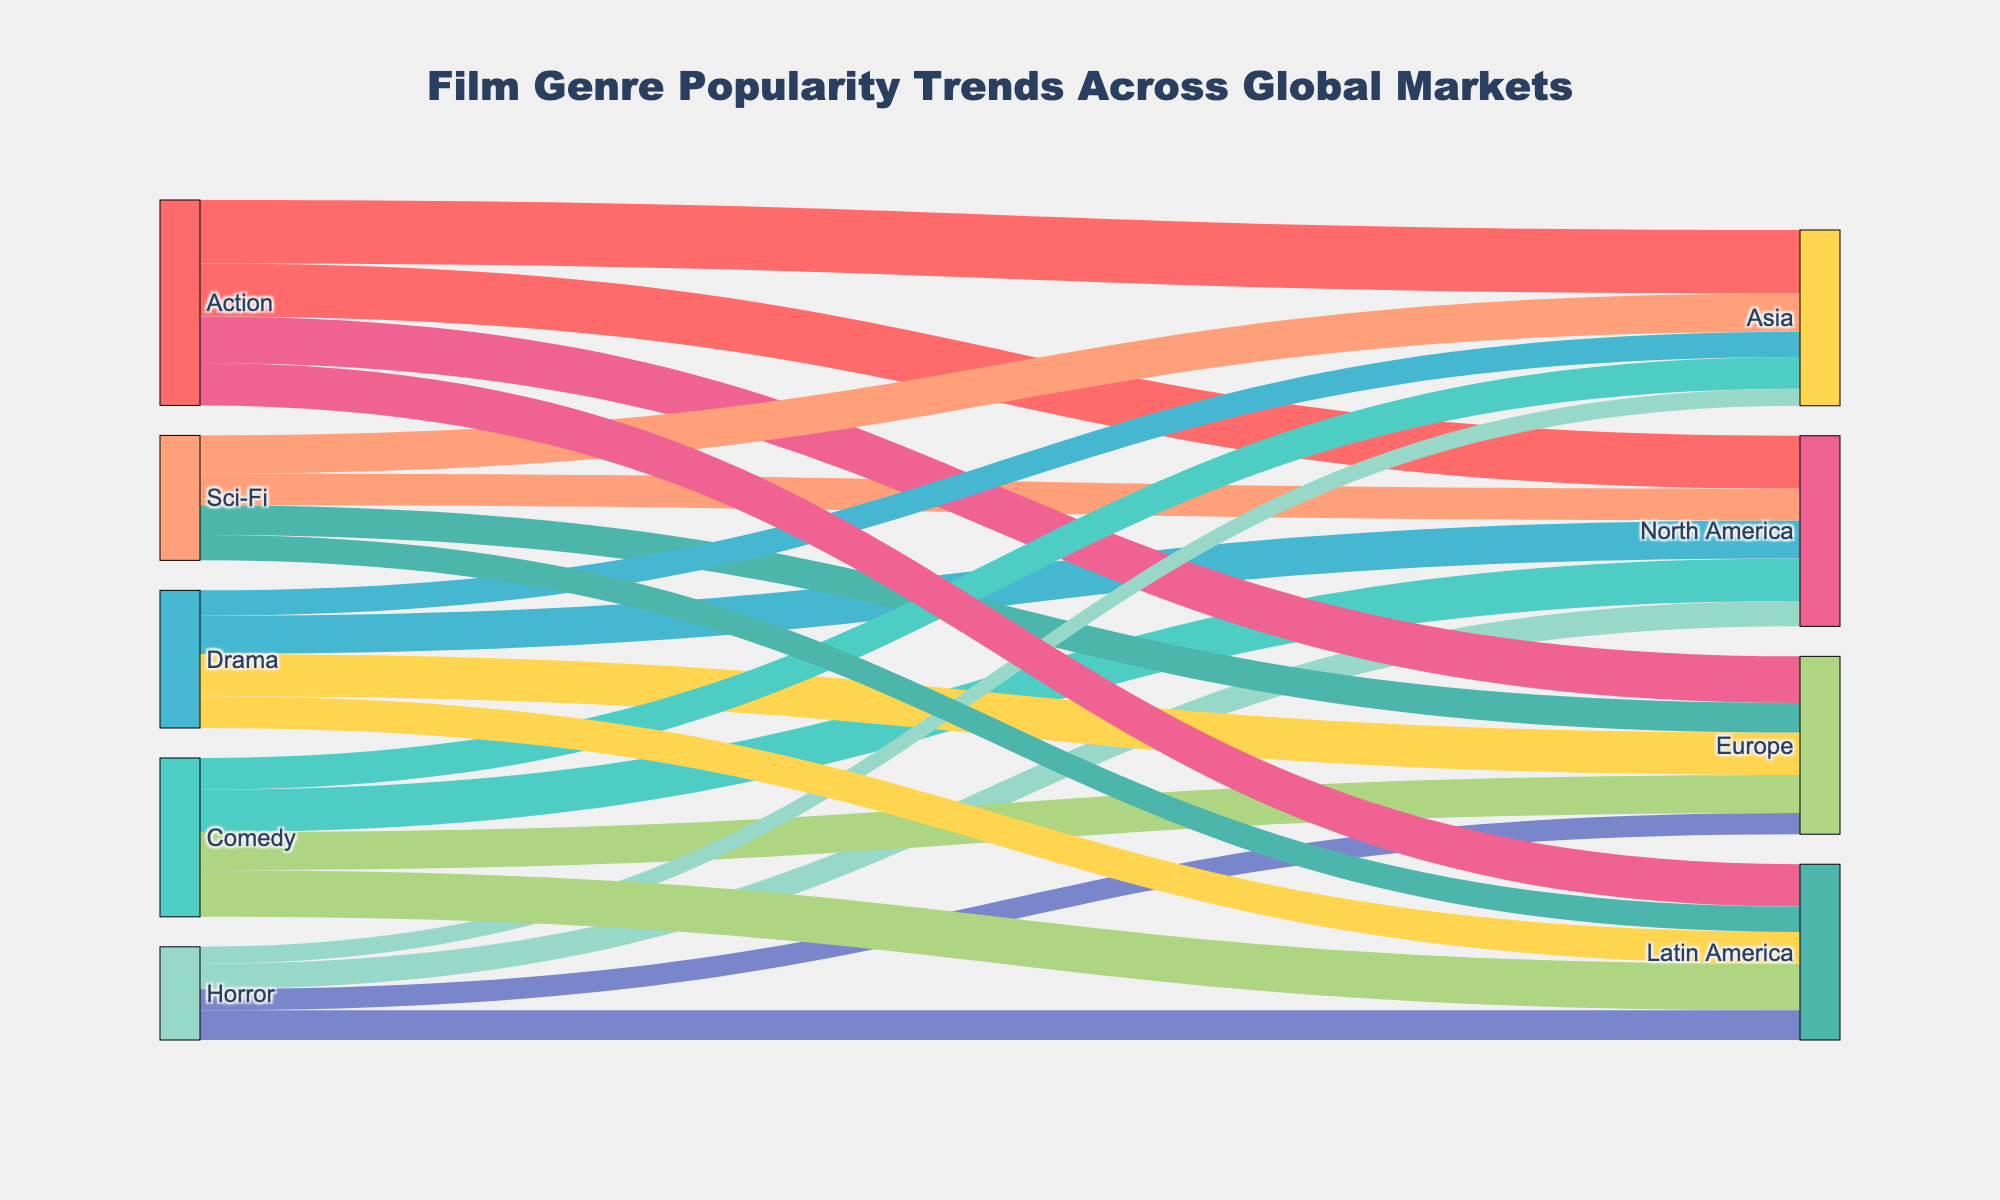What is the most popular film genre in North America? To find the answer, look at the target "North America" and check which source (film genre) has the highest value flowing towards it. The value of 25 for "Action" is the highest.
Answer: Action Which region shows the highest popularity for Comedy films? Scan the "Comedy" row and compare the values flowing towards each region (North America: 20, Europe: 18, Asia: 15, Latin America: 22). Latin America has the maximum value of 22.
Answer: Latin America What is the total value for Drama films across all regions? Sum the values of Drama films for all regions (North America: 18, Europe: 20, Asia: 12, Latin America: 15). The total is 18 + 20 + 12 + 15 = 65.
Answer: 65 Which film genre has the least popularity in Europe? Check the values of different film genres flowing towards Europe and pick the smallest. "Horror" has the value of 10, which is the smallest.
Answer: Horror Compare the popularity of Sci-Fi films between North America and Asia. Which region prefers Sci-Fi more? Look at the values for Sci-Fi films in North America and Asia. The values are North America: 15, Asia: 18. Asia has a higher value, showing a greater preference.
Answer: Asia How does the popularity of Horror films in Latin America compare to that in North America? Compare the values for Horror films in both regions. Latin America: 14, North America: 12. Latin America has a higher value.
Answer: Latin America Which film genre is consistently popular across all regions? Identify the film genre that has relatively high values in each region. "Action" maintains high values across North America (25), Europe (22), Asia (30), and Latin America (20).
Answer: Action 